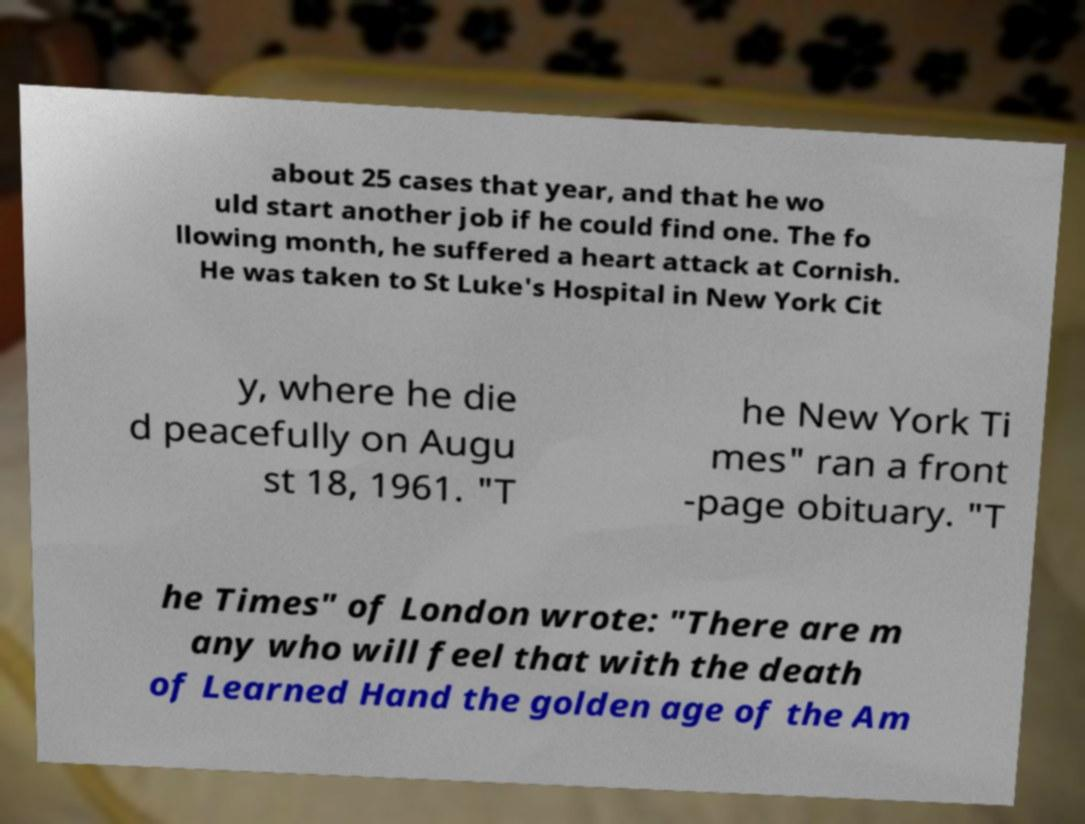What messages or text are displayed in this image? I need them in a readable, typed format. about 25 cases that year, and that he wo uld start another job if he could find one. The fo llowing month, he suffered a heart attack at Cornish. He was taken to St Luke's Hospital in New York Cit y, where he die d peacefully on Augu st 18, 1961. "T he New York Ti mes" ran a front -page obituary. "T he Times" of London wrote: "There are m any who will feel that with the death of Learned Hand the golden age of the Am 